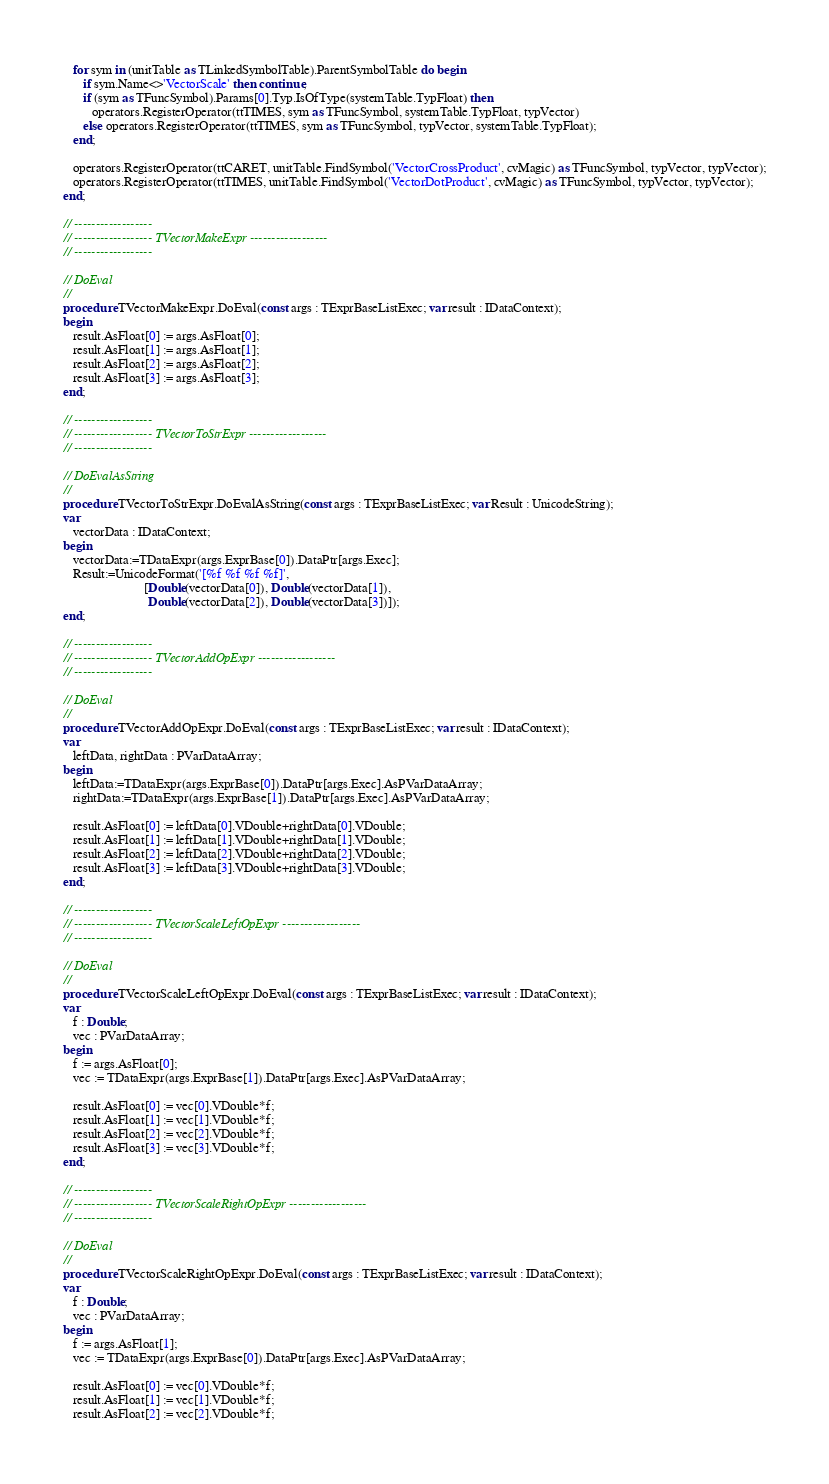<code> <loc_0><loc_0><loc_500><loc_500><_Pascal_>
   for sym in (unitTable as TLinkedSymbolTable).ParentSymbolTable do begin
      if sym.Name<>'VectorScale' then continue;
      if (sym as TFuncSymbol).Params[0].Typ.IsOfType(systemTable.TypFloat) then
         operators.RegisterOperator(ttTIMES, sym as TFuncSymbol, systemTable.TypFloat, typVector)
      else operators.RegisterOperator(ttTIMES, sym as TFuncSymbol, typVector, systemTable.TypFloat);
   end;

   operators.RegisterOperator(ttCARET, unitTable.FindSymbol('VectorCrossProduct', cvMagic) as TFuncSymbol, typVector, typVector);
   operators.RegisterOperator(ttTIMES, unitTable.FindSymbol('VectorDotProduct', cvMagic) as TFuncSymbol, typVector, typVector);
end;

// ------------------
// ------------------ TVectorMakeExpr ------------------
// ------------------

// DoEval
//
procedure TVectorMakeExpr.DoEval(const args : TExprBaseListExec; var result : IDataContext);
begin
   result.AsFloat[0] := args.AsFloat[0];
   result.AsFloat[1] := args.AsFloat[1];
   result.AsFloat[2] := args.AsFloat[2];
   result.AsFloat[3] := args.AsFloat[3];
end;

// ------------------
// ------------------ TVectorToStrExpr ------------------
// ------------------

// DoEvalAsString
//
procedure TVectorToStrExpr.DoEvalAsString(const args : TExprBaseListExec; var Result : UnicodeString);
var
   vectorData : IDataContext;
begin
   vectorData:=TDataExpr(args.ExprBase[0]).DataPtr[args.Exec];
   Result:=UnicodeFormat('[%f %f %f %f]',
                         [Double(vectorData[0]), Double(vectorData[1]),
                          Double(vectorData[2]), Double(vectorData[3])]);
end;

// ------------------
// ------------------ TVectorAddOpExpr ------------------
// ------------------

// DoEval
//
procedure TVectorAddOpExpr.DoEval(const args : TExprBaseListExec; var result : IDataContext);
var
   leftData, rightData : PVarDataArray;
begin
   leftData:=TDataExpr(args.ExprBase[0]).DataPtr[args.Exec].AsPVarDataArray;
   rightData:=TDataExpr(args.ExprBase[1]).DataPtr[args.Exec].AsPVarDataArray;

   result.AsFloat[0] := leftData[0].VDouble+rightData[0].VDouble;
   result.AsFloat[1] := leftData[1].VDouble+rightData[1].VDouble;
   result.AsFloat[2] := leftData[2].VDouble+rightData[2].VDouble;
   result.AsFloat[3] := leftData[3].VDouble+rightData[3].VDouble;
end;

// ------------------
// ------------------ TVectorScaleLeftOpExpr ------------------
// ------------------

// DoEval
//
procedure TVectorScaleLeftOpExpr.DoEval(const args : TExprBaseListExec; var result : IDataContext);
var
   f : Double;
   vec : PVarDataArray;
begin
   f := args.AsFloat[0];
   vec := TDataExpr(args.ExprBase[1]).DataPtr[args.Exec].AsPVarDataArray;

   result.AsFloat[0] := vec[0].VDouble*f;
   result.AsFloat[1] := vec[1].VDouble*f;
   result.AsFloat[2] := vec[2].VDouble*f;
   result.AsFloat[3] := vec[3].VDouble*f;
end;

// ------------------
// ------------------ TVectorScaleRightOpExpr ------------------
// ------------------

// DoEval
//
procedure TVectorScaleRightOpExpr.DoEval(const args : TExprBaseListExec; var result : IDataContext);
var
   f : Double;
   vec : PVarDataArray;
begin
   f := args.AsFloat[1];
   vec := TDataExpr(args.ExprBase[0]).DataPtr[args.Exec].AsPVarDataArray;

   result.AsFloat[0] := vec[0].VDouble*f;
   result.AsFloat[1] := vec[1].VDouble*f;
   result.AsFloat[2] := vec[2].VDouble*f;</code> 